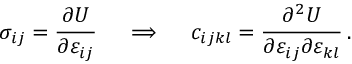Convert formula to latex. <formula><loc_0><loc_0><loc_500><loc_500>\sigma _ { i j } = { \frac { \partial U } { \partial \varepsilon _ { i j } } } \quad \implies \quad c _ { i j k l } = { \frac { \partial ^ { 2 } U } { \partial \varepsilon _ { i j } \partial \varepsilon _ { k l } } } \, .</formula> 